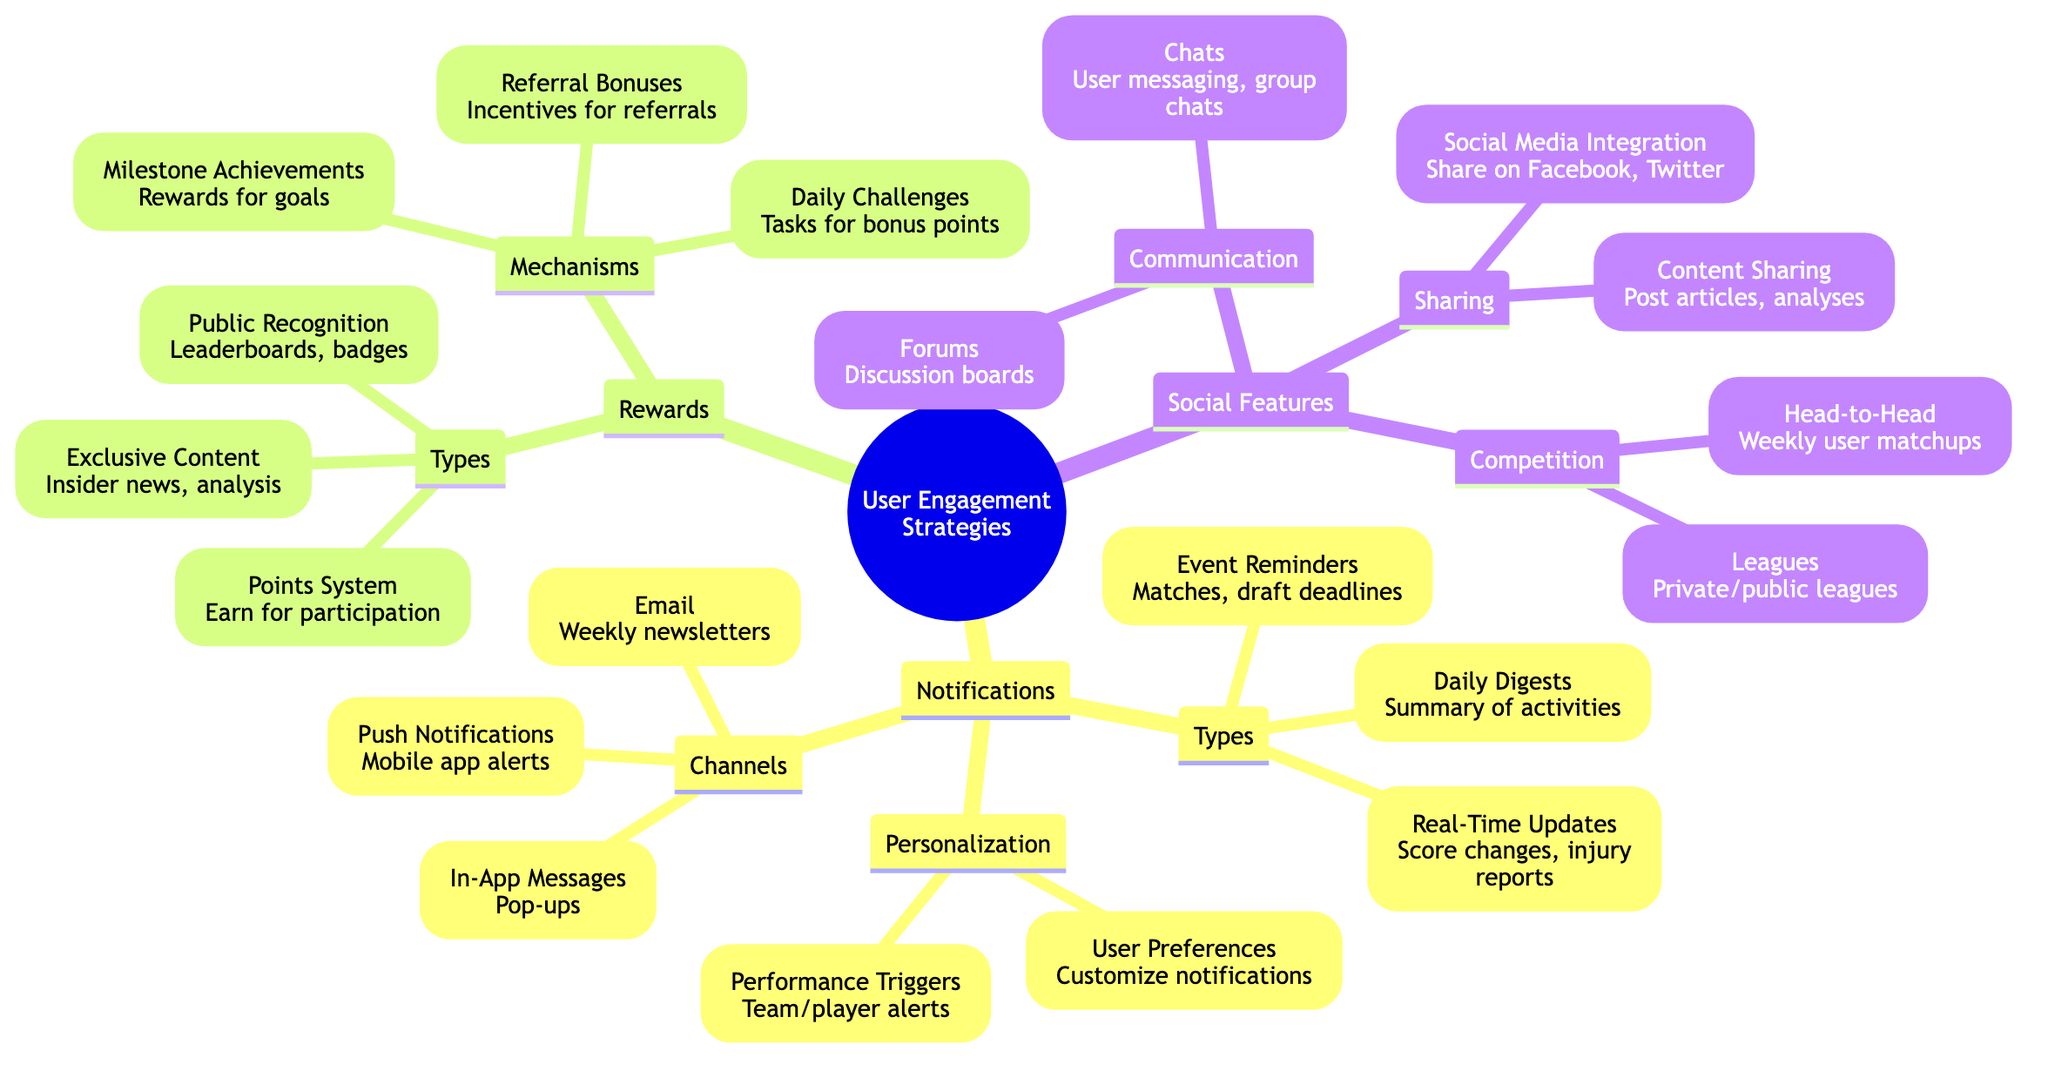What are the three main categories under User Engagement Strategies? The diagram lists three main categories: Notifications, Rewards, and Social Features, which are the primary strategies for user engagement.
Answer: Notifications, Rewards, Social Features How many types of notifications are listed? Under the Notifications category, there are three types identified: Real-Time Updates, Daily Digests, and Event Reminders, making a total of three types.
Answer: 3 What type of rewards can users earn for participation? The diagram indicates that users can earn rewards through a Points System, which is designed to recognize their participation and activities.
Answer: Points System Which social feature allows user-to-user messaging? The Chats feature under Communication allows user-to-user messaging, facilitating direct interaction between users on the platform.
Answer: Chats How many mechanisms for rewards are mentioned? There are three mechanisms listed under the Rewards category: Daily Challenges, Milestone Achievements, and Referral Bonuses, leading to a total of three mechanisms.
Answer: 3 What kind of updates are classified as Real-Time? Real-Time Updates include score changes and injury reports, which provide users with immediate, relevant information about gameplay.
Answer: Score changes, injury reports What can users share via Social Media Integration? Users can share achievements on platforms like Facebook and Twitter, which promotes interaction and engagement beyond the fantasy league platform.
Answer: Achievements Which feature allows users to create or join leagues? The Leagues feature under Competition provides the ability for users to either create private leagues or join public leagues.
Answer: Leagues What is a type of reward for reaching specific goals? Milestone Achievements serve as rewards specifically designed for users who reach certain goals within the engagement platform.
Answer: Milestone Achievements 